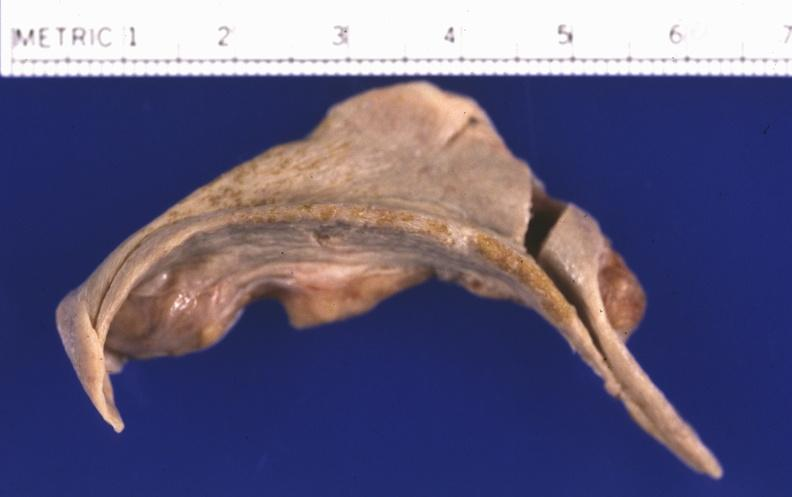does this image show spleen, atrophy and fibrosis?
Answer the question using a single word or phrase. Yes 